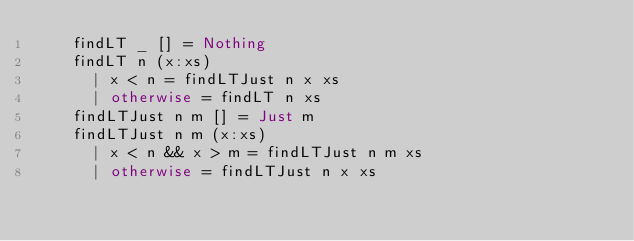<code> <loc_0><loc_0><loc_500><loc_500><_Haskell_>    findLT _ [] = Nothing
    findLT n (x:xs)
      | x < n = findLTJust n x xs
      | otherwise = findLT n xs
    findLTJust n m [] = Just m
    findLTJust n m (x:xs)
      | x < n && x > m = findLTJust n m xs
      | otherwise = findLTJust n x xs
</code> 